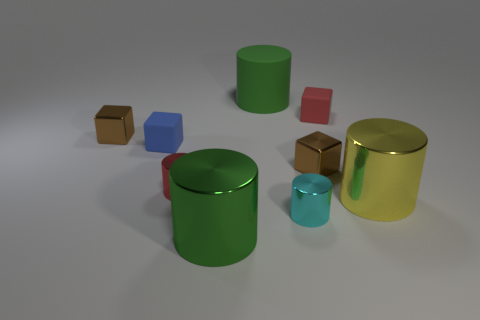Subtract all rubber cylinders. How many cylinders are left? 4 Subtract all cyan cylinders. How many cylinders are left? 4 Subtract all brown cylinders. Subtract all gray balls. How many cylinders are left? 5 Add 1 big brown rubber objects. How many objects exist? 10 Subtract all cubes. How many objects are left? 5 Subtract all blue objects. Subtract all brown metal things. How many objects are left? 6 Add 1 red blocks. How many red blocks are left? 2 Add 9 small blue objects. How many small blue objects exist? 10 Subtract 0 cyan balls. How many objects are left? 9 